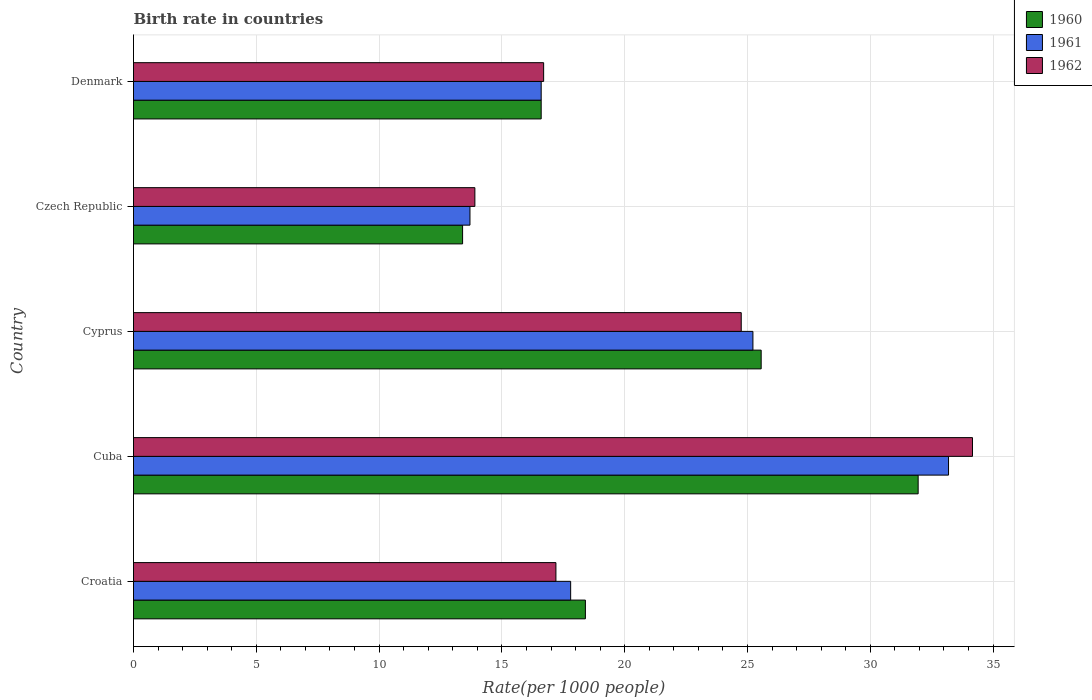How many different coloured bars are there?
Keep it short and to the point. 3. Are the number of bars per tick equal to the number of legend labels?
Your answer should be compact. Yes. Are the number of bars on each tick of the Y-axis equal?
Your answer should be compact. Yes. How many bars are there on the 4th tick from the top?
Your answer should be compact. 3. What is the label of the 1st group of bars from the top?
Give a very brief answer. Denmark. What is the birth rate in 1960 in Cyprus?
Provide a short and direct response. 25.56. Across all countries, what is the maximum birth rate in 1960?
Provide a short and direct response. 31.95. In which country was the birth rate in 1960 maximum?
Offer a very short reply. Cuba. In which country was the birth rate in 1961 minimum?
Offer a very short reply. Czech Republic. What is the total birth rate in 1961 in the graph?
Provide a short and direct response. 106.51. What is the difference between the birth rate in 1962 in Croatia and that in Cyprus?
Provide a succinct answer. -7.55. What is the difference between the birth rate in 1960 in Denmark and the birth rate in 1962 in Cuba?
Make the answer very short. -17.56. What is the average birth rate in 1960 per country?
Provide a succinct answer. 21.18. What is the difference between the birth rate in 1961 and birth rate in 1962 in Czech Republic?
Offer a terse response. -0.2. In how many countries, is the birth rate in 1961 greater than 31 ?
Offer a terse response. 1. What is the ratio of the birth rate in 1961 in Croatia to that in Cuba?
Keep it short and to the point. 0.54. Is the birth rate in 1962 in Cuba less than that in Denmark?
Your answer should be compact. No. Is the difference between the birth rate in 1961 in Croatia and Denmark greater than the difference between the birth rate in 1962 in Croatia and Denmark?
Provide a short and direct response. Yes. What is the difference between the highest and the second highest birth rate in 1960?
Your answer should be very brief. 6.39. What is the difference between the highest and the lowest birth rate in 1960?
Offer a terse response. 18.55. What is the difference between two consecutive major ticks on the X-axis?
Make the answer very short. 5. Does the graph contain grids?
Offer a terse response. Yes. How many legend labels are there?
Give a very brief answer. 3. How are the legend labels stacked?
Your answer should be compact. Vertical. What is the title of the graph?
Provide a succinct answer. Birth rate in countries. Does "1974" appear as one of the legend labels in the graph?
Keep it short and to the point. No. What is the label or title of the X-axis?
Give a very brief answer. Rate(per 1000 people). What is the Rate(per 1000 people) in 1961 in Croatia?
Your answer should be compact. 17.8. What is the Rate(per 1000 people) of 1960 in Cuba?
Make the answer very short. 31.95. What is the Rate(per 1000 people) in 1961 in Cuba?
Your answer should be very brief. 33.19. What is the Rate(per 1000 people) of 1962 in Cuba?
Keep it short and to the point. 34.16. What is the Rate(per 1000 people) in 1960 in Cyprus?
Give a very brief answer. 25.56. What is the Rate(per 1000 people) in 1961 in Cyprus?
Your answer should be very brief. 25.22. What is the Rate(per 1000 people) of 1962 in Cyprus?
Provide a succinct answer. 24.75. What is the Rate(per 1000 people) of 1961 in Denmark?
Offer a very short reply. 16.6. What is the Rate(per 1000 people) of 1962 in Denmark?
Keep it short and to the point. 16.7. Across all countries, what is the maximum Rate(per 1000 people) of 1960?
Give a very brief answer. 31.95. Across all countries, what is the maximum Rate(per 1000 people) of 1961?
Your answer should be compact. 33.19. Across all countries, what is the maximum Rate(per 1000 people) of 1962?
Your response must be concise. 34.16. Across all countries, what is the minimum Rate(per 1000 people) in 1960?
Your response must be concise. 13.4. Across all countries, what is the minimum Rate(per 1000 people) in 1961?
Give a very brief answer. 13.7. Across all countries, what is the minimum Rate(per 1000 people) of 1962?
Your answer should be compact. 13.9. What is the total Rate(per 1000 people) in 1960 in the graph?
Offer a very short reply. 105.91. What is the total Rate(per 1000 people) of 1961 in the graph?
Keep it short and to the point. 106.51. What is the total Rate(per 1000 people) of 1962 in the graph?
Provide a succinct answer. 106.71. What is the difference between the Rate(per 1000 people) in 1960 in Croatia and that in Cuba?
Offer a terse response. -13.55. What is the difference between the Rate(per 1000 people) in 1961 in Croatia and that in Cuba?
Your answer should be very brief. -15.39. What is the difference between the Rate(per 1000 people) of 1962 in Croatia and that in Cuba?
Make the answer very short. -16.96. What is the difference between the Rate(per 1000 people) in 1960 in Croatia and that in Cyprus?
Give a very brief answer. -7.16. What is the difference between the Rate(per 1000 people) of 1961 in Croatia and that in Cyprus?
Offer a very short reply. -7.42. What is the difference between the Rate(per 1000 people) in 1962 in Croatia and that in Cyprus?
Provide a short and direct response. -7.55. What is the difference between the Rate(per 1000 people) in 1960 in Croatia and that in Czech Republic?
Your response must be concise. 5. What is the difference between the Rate(per 1000 people) in 1961 in Croatia and that in Czech Republic?
Your answer should be very brief. 4.1. What is the difference between the Rate(per 1000 people) in 1962 in Croatia and that in Czech Republic?
Offer a very short reply. 3.3. What is the difference between the Rate(per 1000 people) in 1960 in Croatia and that in Denmark?
Your answer should be compact. 1.8. What is the difference between the Rate(per 1000 people) in 1961 in Croatia and that in Denmark?
Give a very brief answer. 1.2. What is the difference between the Rate(per 1000 people) of 1962 in Croatia and that in Denmark?
Your response must be concise. 0.5. What is the difference between the Rate(per 1000 people) of 1960 in Cuba and that in Cyprus?
Your response must be concise. 6.39. What is the difference between the Rate(per 1000 people) in 1961 in Cuba and that in Cyprus?
Provide a succinct answer. 7.96. What is the difference between the Rate(per 1000 people) in 1962 in Cuba and that in Cyprus?
Your answer should be very brief. 9.42. What is the difference between the Rate(per 1000 people) in 1960 in Cuba and that in Czech Republic?
Provide a short and direct response. 18.55. What is the difference between the Rate(per 1000 people) in 1961 in Cuba and that in Czech Republic?
Ensure brevity in your answer.  19.49. What is the difference between the Rate(per 1000 people) in 1962 in Cuba and that in Czech Republic?
Make the answer very short. 20.26. What is the difference between the Rate(per 1000 people) of 1960 in Cuba and that in Denmark?
Offer a terse response. 15.35. What is the difference between the Rate(per 1000 people) of 1961 in Cuba and that in Denmark?
Your response must be concise. 16.59. What is the difference between the Rate(per 1000 people) in 1962 in Cuba and that in Denmark?
Your answer should be compact. 17.46. What is the difference between the Rate(per 1000 people) of 1960 in Cyprus and that in Czech Republic?
Keep it short and to the point. 12.16. What is the difference between the Rate(per 1000 people) in 1961 in Cyprus and that in Czech Republic?
Ensure brevity in your answer.  11.52. What is the difference between the Rate(per 1000 people) of 1962 in Cyprus and that in Czech Republic?
Ensure brevity in your answer.  10.85. What is the difference between the Rate(per 1000 people) in 1960 in Cyprus and that in Denmark?
Ensure brevity in your answer.  8.96. What is the difference between the Rate(per 1000 people) of 1961 in Cyprus and that in Denmark?
Your answer should be compact. 8.62. What is the difference between the Rate(per 1000 people) in 1962 in Cyprus and that in Denmark?
Keep it short and to the point. 8.05. What is the difference between the Rate(per 1000 people) in 1960 in Czech Republic and that in Denmark?
Offer a terse response. -3.2. What is the difference between the Rate(per 1000 people) in 1961 in Czech Republic and that in Denmark?
Provide a succinct answer. -2.9. What is the difference between the Rate(per 1000 people) of 1962 in Czech Republic and that in Denmark?
Offer a terse response. -2.8. What is the difference between the Rate(per 1000 people) of 1960 in Croatia and the Rate(per 1000 people) of 1961 in Cuba?
Your answer should be very brief. -14.79. What is the difference between the Rate(per 1000 people) of 1960 in Croatia and the Rate(per 1000 people) of 1962 in Cuba?
Ensure brevity in your answer.  -15.76. What is the difference between the Rate(per 1000 people) of 1961 in Croatia and the Rate(per 1000 people) of 1962 in Cuba?
Your response must be concise. -16.36. What is the difference between the Rate(per 1000 people) in 1960 in Croatia and the Rate(per 1000 people) in 1961 in Cyprus?
Your response must be concise. -6.82. What is the difference between the Rate(per 1000 people) in 1960 in Croatia and the Rate(per 1000 people) in 1962 in Cyprus?
Your answer should be very brief. -6.35. What is the difference between the Rate(per 1000 people) of 1961 in Croatia and the Rate(per 1000 people) of 1962 in Cyprus?
Provide a short and direct response. -6.95. What is the difference between the Rate(per 1000 people) of 1960 in Croatia and the Rate(per 1000 people) of 1961 in Czech Republic?
Provide a short and direct response. 4.7. What is the difference between the Rate(per 1000 people) in 1961 in Croatia and the Rate(per 1000 people) in 1962 in Czech Republic?
Your answer should be very brief. 3.9. What is the difference between the Rate(per 1000 people) in 1960 in Croatia and the Rate(per 1000 people) in 1961 in Denmark?
Provide a succinct answer. 1.8. What is the difference between the Rate(per 1000 people) of 1960 in Cuba and the Rate(per 1000 people) of 1961 in Cyprus?
Provide a short and direct response. 6.73. What is the difference between the Rate(per 1000 people) in 1960 in Cuba and the Rate(per 1000 people) in 1962 in Cyprus?
Ensure brevity in your answer.  7.2. What is the difference between the Rate(per 1000 people) of 1961 in Cuba and the Rate(per 1000 people) of 1962 in Cyprus?
Ensure brevity in your answer.  8.44. What is the difference between the Rate(per 1000 people) in 1960 in Cuba and the Rate(per 1000 people) in 1961 in Czech Republic?
Your response must be concise. 18.25. What is the difference between the Rate(per 1000 people) of 1960 in Cuba and the Rate(per 1000 people) of 1962 in Czech Republic?
Keep it short and to the point. 18.05. What is the difference between the Rate(per 1000 people) in 1961 in Cuba and the Rate(per 1000 people) in 1962 in Czech Republic?
Your response must be concise. 19.29. What is the difference between the Rate(per 1000 people) of 1960 in Cuba and the Rate(per 1000 people) of 1961 in Denmark?
Offer a terse response. 15.35. What is the difference between the Rate(per 1000 people) in 1960 in Cuba and the Rate(per 1000 people) in 1962 in Denmark?
Your response must be concise. 15.25. What is the difference between the Rate(per 1000 people) of 1961 in Cuba and the Rate(per 1000 people) of 1962 in Denmark?
Make the answer very short. 16.49. What is the difference between the Rate(per 1000 people) of 1960 in Cyprus and the Rate(per 1000 people) of 1961 in Czech Republic?
Offer a terse response. 11.86. What is the difference between the Rate(per 1000 people) of 1960 in Cyprus and the Rate(per 1000 people) of 1962 in Czech Republic?
Your answer should be very brief. 11.66. What is the difference between the Rate(per 1000 people) of 1961 in Cyprus and the Rate(per 1000 people) of 1962 in Czech Republic?
Ensure brevity in your answer.  11.32. What is the difference between the Rate(per 1000 people) of 1960 in Cyprus and the Rate(per 1000 people) of 1961 in Denmark?
Keep it short and to the point. 8.96. What is the difference between the Rate(per 1000 people) of 1960 in Cyprus and the Rate(per 1000 people) of 1962 in Denmark?
Provide a succinct answer. 8.86. What is the difference between the Rate(per 1000 people) of 1961 in Cyprus and the Rate(per 1000 people) of 1962 in Denmark?
Offer a terse response. 8.52. What is the difference between the Rate(per 1000 people) in 1960 in Czech Republic and the Rate(per 1000 people) in 1962 in Denmark?
Offer a terse response. -3.3. What is the difference between the Rate(per 1000 people) of 1961 in Czech Republic and the Rate(per 1000 people) of 1962 in Denmark?
Your answer should be compact. -3. What is the average Rate(per 1000 people) of 1960 per country?
Keep it short and to the point. 21.18. What is the average Rate(per 1000 people) in 1961 per country?
Your answer should be very brief. 21.3. What is the average Rate(per 1000 people) of 1962 per country?
Keep it short and to the point. 21.34. What is the difference between the Rate(per 1000 people) of 1960 and Rate(per 1000 people) of 1961 in Croatia?
Offer a terse response. 0.6. What is the difference between the Rate(per 1000 people) in 1960 and Rate(per 1000 people) in 1961 in Cuba?
Ensure brevity in your answer.  -1.24. What is the difference between the Rate(per 1000 people) in 1960 and Rate(per 1000 people) in 1962 in Cuba?
Your answer should be very brief. -2.21. What is the difference between the Rate(per 1000 people) of 1961 and Rate(per 1000 people) of 1962 in Cuba?
Make the answer very short. -0.97. What is the difference between the Rate(per 1000 people) in 1960 and Rate(per 1000 people) in 1961 in Cyprus?
Your answer should be compact. 0.34. What is the difference between the Rate(per 1000 people) in 1960 and Rate(per 1000 people) in 1962 in Cyprus?
Give a very brief answer. 0.81. What is the difference between the Rate(per 1000 people) in 1961 and Rate(per 1000 people) in 1962 in Cyprus?
Give a very brief answer. 0.48. What is the difference between the Rate(per 1000 people) of 1960 and Rate(per 1000 people) of 1961 in Czech Republic?
Your response must be concise. -0.3. What is the difference between the Rate(per 1000 people) in 1960 and Rate(per 1000 people) in 1962 in Denmark?
Your response must be concise. -0.1. What is the difference between the Rate(per 1000 people) in 1961 and Rate(per 1000 people) in 1962 in Denmark?
Offer a very short reply. -0.1. What is the ratio of the Rate(per 1000 people) of 1960 in Croatia to that in Cuba?
Provide a succinct answer. 0.58. What is the ratio of the Rate(per 1000 people) of 1961 in Croatia to that in Cuba?
Your answer should be compact. 0.54. What is the ratio of the Rate(per 1000 people) of 1962 in Croatia to that in Cuba?
Provide a succinct answer. 0.5. What is the ratio of the Rate(per 1000 people) of 1960 in Croatia to that in Cyprus?
Offer a terse response. 0.72. What is the ratio of the Rate(per 1000 people) in 1961 in Croatia to that in Cyprus?
Your answer should be very brief. 0.71. What is the ratio of the Rate(per 1000 people) in 1962 in Croatia to that in Cyprus?
Make the answer very short. 0.7. What is the ratio of the Rate(per 1000 people) in 1960 in Croatia to that in Czech Republic?
Keep it short and to the point. 1.37. What is the ratio of the Rate(per 1000 people) of 1961 in Croatia to that in Czech Republic?
Your answer should be compact. 1.3. What is the ratio of the Rate(per 1000 people) of 1962 in Croatia to that in Czech Republic?
Give a very brief answer. 1.24. What is the ratio of the Rate(per 1000 people) in 1960 in Croatia to that in Denmark?
Provide a succinct answer. 1.11. What is the ratio of the Rate(per 1000 people) in 1961 in Croatia to that in Denmark?
Keep it short and to the point. 1.07. What is the ratio of the Rate(per 1000 people) of 1962 in Croatia to that in Denmark?
Your answer should be compact. 1.03. What is the ratio of the Rate(per 1000 people) in 1960 in Cuba to that in Cyprus?
Ensure brevity in your answer.  1.25. What is the ratio of the Rate(per 1000 people) of 1961 in Cuba to that in Cyprus?
Offer a very short reply. 1.32. What is the ratio of the Rate(per 1000 people) in 1962 in Cuba to that in Cyprus?
Your answer should be very brief. 1.38. What is the ratio of the Rate(per 1000 people) of 1960 in Cuba to that in Czech Republic?
Keep it short and to the point. 2.38. What is the ratio of the Rate(per 1000 people) in 1961 in Cuba to that in Czech Republic?
Ensure brevity in your answer.  2.42. What is the ratio of the Rate(per 1000 people) in 1962 in Cuba to that in Czech Republic?
Make the answer very short. 2.46. What is the ratio of the Rate(per 1000 people) in 1960 in Cuba to that in Denmark?
Offer a terse response. 1.92. What is the ratio of the Rate(per 1000 people) in 1961 in Cuba to that in Denmark?
Provide a short and direct response. 2. What is the ratio of the Rate(per 1000 people) of 1962 in Cuba to that in Denmark?
Keep it short and to the point. 2.05. What is the ratio of the Rate(per 1000 people) in 1960 in Cyprus to that in Czech Republic?
Make the answer very short. 1.91. What is the ratio of the Rate(per 1000 people) of 1961 in Cyprus to that in Czech Republic?
Offer a very short reply. 1.84. What is the ratio of the Rate(per 1000 people) in 1962 in Cyprus to that in Czech Republic?
Your answer should be compact. 1.78. What is the ratio of the Rate(per 1000 people) of 1960 in Cyprus to that in Denmark?
Your response must be concise. 1.54. What is the ratio of the Rate(per 1000 people) of 1961 in Cyprus to that in Denmark?
Offer a very short reply. 1.52. What is the ratio of the Rate(per 1000 people) of 1962 in Cyprus to that in Denmark?
Provide a succinct answer. 1.48. What is the ratio of the Rate(per 1000 people) in 1960 in Czech Republic to that in Denmark?
Your response must be concise. 0.81. What is the ratio of the Rate(per 1000 people) of 1961 in Czech Republic to that in Denmark?
Give a very brief answer. 0.83. What is the ratio of the Rate(per 1000 people) of 1962 in Czech Republic to that in Denmark?
Your response must be concise. 0.83. What is the difference between the highest and the second highest Rate(per 1000 people) of 1960?
Offer a very short reply. 6.39. What is the difference between the highest and the second highest Rate(per 1000 people) of 1961?
Your answer should be compact. 7.96. What is the difference between the highest and the second highest Rate(per 1000 people) of 1962?
Your response must be concise. 9.42. What is the difference between the highest and the lowest Rate(per 1000 people) in 1960?
Offer a very short reply. 18.55. What is the difference between the highest and the lowest Rate(per 1000 people) in 1961?
Ensure brevity in your answer.  19.49. What is the difference between the highest and the lowest Rate(per 1000 people) in 1962?
Give a very brief answer. 20.26. 